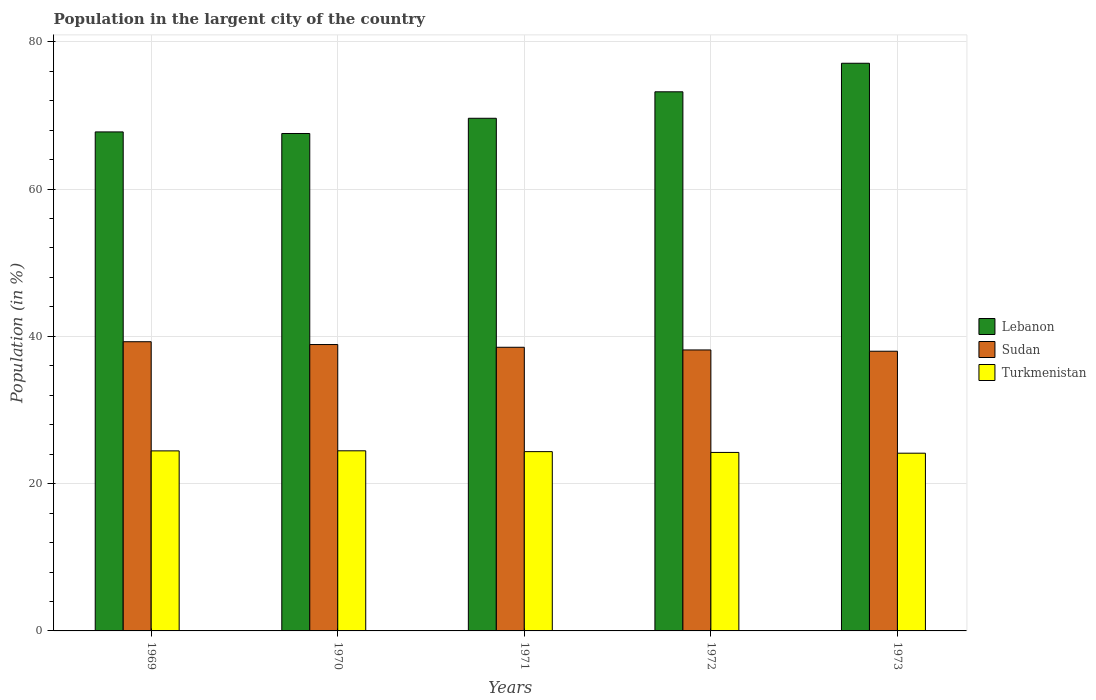How many bars are there on the 3rd tick from the left?
Your response must be concise. 3. In how many cases, is the number of bars for a given year not equal to the number of legend labels?
Offer a terse response. 0. What is the percentage of population in the largent city in Turkmenistan in 1973?
Provide a succinct answer. 24.13. Across all years, what is the maximum percentage of population in the largent city in Sudan?
Keep it short and to the point. 39.27. Across all years, what is the minimum percentage of population in the largent city in Lebanon?
Give a very brief answer. 67.54. What is the total percentage of population in the largent city in Sudan in the graph?
Keep it short and to the point. 192.79. What is the difference between the percentage of population in the largent city in Turkmenistan in 1969 and that in 1972?
Give a very brief answer. 0.21. What is the difference between the percentage of population in the largent city in Sudan in 1972 and the percentage of population in the largent city in Lebanon in 1971?
Ensure brevity in your answer.  -31.45. What is the average percentage of population in the largent city in Turkmenistan per year?
Keep it short and to the point. 24.32. In the year 1973, what is the difference between the percentage of population in the largent city in Sudan and percentage of population in the largent city in Lebanon?
Ensure brevity in your answer.  -39.1. What is the ratio of the percentage of population in the largent city in Turkmenistan in 1970 to that in 1972?
Provide a succinct answer. 1.01. Is the percentage of population in the largent city in Turkmenistan in 1970 less than that in 1971?
Keep it short and to the point. No. Is the difference between the percentage of population in the largent city in Sudan in 1970 and 1973 greater than the difference between the percentage of population in the largent city in Lebanon in 1970 and 1973?
Your answer should be compact. Yes. What is the difference between the highest and the second highest percentage of population in the largent city in Turkmenistan?
Your response must be concise. 0.01. What is the difference between the highest and the lowest percentage of population in the largent city in Sudan?
Your answer should be compact. 1.29. In how many years, is the percentage of population in the largent city in Sudan greater than the average percentage of population in the largent city in Sudan taken over all years?
Provide a succinct answer. 2. What does the 1st bar from the left in 1971 represents?
Provide a succinct answer. Lebanon. What does the 3rd bar from the right in 1969 represents?
Your answer should be compact. Lebanon. Is it the case that in every year, the sum of the percentage of population in the largent city in Turkmenistan and percentage of population in the largent city in Sudan is greater than the percentage of population in the largent city in Lebanon?
Your answer should be compact. No. How many bars are there?
Offer a terse response. 15. Are all the bars in the graph horizontal?
Make the answer very short. No. Are the values on the major ticks of Y-axis written in scientific E-notation?
Offer a terse response. No. Does the graph contain any zero values?
Offer a terse response. No. Does the graph contain grids?
Offer a terse response. Yes. Where does the legend appear in the graph?
Provide a succinct answer. Center right. How are the legend labels stacked?
Make the answer very short. Vertical. What is the title of the graph?
Your answer should be very brief. Population in the largent city of the country. Does "Cuba" appear as one of the legend labels in the graph?
Your response must be concise. No. What is the label or title of the X-axis?
Your response must be concise. Years. What is the Population (in %) of Lebanon in 1969?
Your answer should be very brief. 67.75. What is the Population (in %) of Sudan in 1969?
Your answer should be compact. 39.27. What is the Population (in %) in Turkmenistan in 1969?
Offer a very short reply. 24.44. What is the Population (in %) in Lebanon in 1970?
Offer a very short reply. 67.54. What is the Population (in %) of Sudan in 1970?
Ensure brevity in your answer.  38.88. What is the Population (in %) in Turkmenistan in 1970?
Provide a succinct answer. 24.45. What is the Population (in %) of Lebanon in 1971?
Your answer should be compact. 69.6. What is the Population (in %) in Sudan in 1971?
Offer a very short reply. 38.51. What is the Population (in %) in Turkmenistan in 1971?
Ensure brevity in your answer.  24.34. What is the Population (in %) in Lebanon in 1972?
Your answer should be compact. 73.2. What is the Population (in %) in Sudan in 1972?
Provide a succinct answer. 38.15. What is the Population (in %) of Turkmenistan in 1972?
Offer a very short reply. 24.23. What is the Population (in %) of Lebanon in 1973?
Your answer should be compact. 77.07. What is the Population (in %) in Sudan in 1973?
Provide a short and direct response. 37.98. What is the Population (in %) in Turkmenistan in 1973?
Ensure brevity in your answer.  24.13. Across all years, what is the maximum Population (in %) of Lebanon?
Your answer should be compact. 77.07. Across all years, what is the maximum Population (in %) in Sudan?
Your response must be concise. 39.27. Across all years, what is the maximum Population (in %) in Turkmenistan?
Your answer should be very brief. 24.45. Across all years, what is the minimum Population (in %) in Lebanon?
Your answer should be very brief. 67.54. Across all years, what is the minimum Population (in %) in Sudan?
Offer a terse response. 37.98. Across all years, what is the minimum Population (in %) of Turkmenistan?
Make the answer very short. 24.13. What is the total Population (in %) in Lebanon in the graph?
Your response must be concise. 355.17. What is the total Population (in %) in Sudan in the graph?
Provide a succinct answer. 192.79. What is the total Population (in %) of Turkmenistan in the graph?
Your answer should be very brief. 121.61. What is the difference between the Population (in %) of Lebanon in 1969 and that in 1970?
Offer a terse response. 0.21. What is the difference between the Population (in %) in Sudan in 1969 and that in 1970?
Your answer should be compact. 0.38. What is the difference between the Population (in %) of Turkmenistan in 1969 and that in 1970?
Make the answer very short. -0.01. What is the difference between the Population (in %) of Lebanon in 1969 and that in 1971?
Ensure brevity in your answer.  -1.85. What is the difference between the Population (in %) in Sudan in 1969 and that in 1971?
Keep it short and to the point. 0.76. What is the difference between the Population (in %) in Turkmenistan in 1969 and that in 1971?
Offer a very short reply. 0.1. What is the difference between the Population (in %) in Lebanon in 1969 and that in 1972?
Provide a short and direct response. -5.45. What is the difference between the Population (in %) of Sudan in 1969 and that in 1972?
Ensure brevity in your answer.  1.12. What is the difference between the Population (in %) in Turkmenistan in 1969 and that in 1972?
Provide a short and direct response. 0.21. What is the difference between the Population (in %) of Lebanon in 1969 and that in 1973?
Your response must be concise. -9.32. What is the difference between the Population (in %) in Sudan in 1969 and that in 1973?
Make the answer very short. 1.29. What is the difference between the Population (in %) of Turkmenistan in 1969 and that in 1973?
Give a very brief answer. 0.31. What is the difference between the Population (in %) in Lebanon in 1970 and that in 1971?
Give a very brief answer. -2.06. What is the difference between the Population (in %) of Sudan in 1970 and that in 1971?
Keep it short and to the point. 0.37. What is the difference between the Population (in %) in Turkmenistan in 1970 and that in 1971?
Offer a very short reply. 0.11. What is the difference between the Population (in %) of Lebanon in 1970 and that in 1972?
Your response must be concise. -5.66. What is the difference between the Population (in %) in Sudan in 1970 and that in 1972?
Provide a succinct answer. 0.73. What is the difference between the Population (in %) of Turkmenistan in 1970 and that in 1972?
Offer a very short reply. 0.22. What is the difference between the Population (in %) in Lebanon in 1970 and that in 1973?
Keep it short and to the point. -9.54. What is the difference between the Population (in %) of Sudan in 1970 and that in 1973?
Provide a succinct answer. 0.91. What is the difference between the Population (in %) of Turkmenistan in 1970 and that in 1973?
Your response must be concise. 0.32. What is the difference between the Population (in %) in Lebanon in 1971 and that in 1972?
Provide a succinct answer. -3.6. What is the difference between the Population (in %) in Sudan in 1971 and that in 1972?
Make the answer very short. 0.36. What is the difference between the Population (in %) of Turkmenistan in 1971 and that in 1972?
Your answer should be very brief. 0.11. What is the difference between the Population (in %) in Lebanon in 1971 and that in 1973?
Ensure brevity in your answer.  -7.47. What is the difference between the Population (in %) of Sudan in 1971 and that in 1973?
Make the answer very short. 0.54. What is the difference between the Population (in %) of Turkmenistan in 1971 and that in 1973?
Provide a short and direct response. 0.21. What is the difference between the Population (in %) of Lebanon in 1972 and that in 1973?
Keep it short and to the point. -3.88. What is the difference between the Population (in %) in Sudan in 1972 and that in 1973?
Keep it short and to the point. 0.17. What is the difference between the Population (in %) in Turkmenistan in 1972 and that in 1973?
Offer a very short reply. 0.1. What is the difference between the Population (in %) of Lebanon in 1969 and the Population (in %) of Sudan in 1970?
Keep it short and to the point. 28.87. What is the difference between the Population (in %) of Lebanon in 1969 and the Population (in %) of Turkmenistan in 1970?
Offer a very short reply. 43.3. What is the difference between the Population (in %) in Sudan in 1969 and the Population (in %) in Turkmenistan in 1970?
Your answer should be compact. 14.81. What is the difference between the Population (in %) in Lebanon in 1969 and the Population (in %) in Sudan in 1971?
Make the answer very short. 29.24. What is the difference between the Population (in %) of Lebanon in 1969 and the Population (in %) of Turkmenistan in 1971?
Ensure brevity in your answer.  43.41. What is the difference between the Population (in %) in Sudan in 1969 and the Population (in %) in Turkmenistan in 1971?
Keep it short and to the point. 14.92. What is the difference between the Population (in %) in Lebanon in 1969 and the Population (in %) in Sudan in 1972?
Provide a succinct answer. 29.6. What is the difference between the Population (in %) in Lebanon in 1969 and the Population (in %) in Turkmenistan in 1972?
Your answer should be very brief. 43.52. What is the difference between the Population (in %) in Sudan in 1969 and the Population (in %) in Turkmenistan in 1972?
Your response must be concise. 15.03. What is the difference between the Population (in %) in Lebanon in 1969 and the Population (in %) in Sudan in 1973?
Your answer should be compact. 29.78. What is the difference between the Population (in %) of Lebanon in 1969 and the Population (in %) of Turkmenistan in 1973?
Offer a very short reply. 43.62. What is the difference between the Population (in %) of Sudan in 1969 and the Population (in %) of Turkmenistan in 1973?
Offer a terse response. 15.14. What is the difference between the Population (in %) of Lebanon in 1970 and the Population (in %) of Sudan in 1971?
Provide a short and direct response. 29.03. What is the difference between the Population (in %) in Lebanon in 1970 and the Population (in %) in Turkmenistan in 1971?
Give a very brief answer. 43.2. What is the difference between the Population (in %) in Sudan in 1970 and the Population (in %) in Turkmenistan in 1971?
Keep it short and to the point. 14.54. What is the difference between the Population (in %) in Lebanon in 1970 and the Population (in %) in Sudan in 1972?
Make the answer very short. 29.39. What is the difference between the Population (in %) in Lebanon in 1970 and the Population (in %) in Turkmenistan in 1972?
Give a very brief answer. 43.3. What is the difference between the Population (in %) in Sudan in 1970 and the Population (in %) in Turkmenistan in 1972?
Provide a short and direct response. 14.65. What is the difference between the Population (in %) in Lebanon in 1970 and the Population (in %) in Sudan in 1973?
Give a very brief answer. 29.56. What is the difference between the Population (in %) of Lebanon in 1970 and the Population (in %) of Turkmenistan in 1973?
Ensure brevity in your answer.  43.41. What is the difference between the Population (in %) in Sudan in 1970 and the Population (in %) in Turkmenistan in 1973?
Give a very brief answer. 14.75. What is the difference between the Population (in %) in Lebanon in 1971 and the Population (in %) in Sudan in 1972?
Offer a very short reply. 31.45. What is the difference between the Population (in %) in Lebanon in 1971 and the Population (in %) in Turkmenistan in 1972?
Provide a short and direct response. 45.37. What is the difference between the Population (in %) of Sudan in 1971 and the Population (in %) of Turkmenistan in 1972?
Keep it short and to the point. 14.28. What is the difference between the Population (in %) of Lebanon in 1971 and the Population (in %) of Sudan in 1973?
Give a very brief answer. 31.63. What is the difference between the Population (in %) in Lebanon in 1971 and the Population (in %) in Turkmenistan in 1973?
Offer a very short reply. 45.47. What is the difference between the Population (in %) in Sudan in 1971 and the Population (in %) in Turkmenistan in 1973?
Your answer should be compact. 14.38. What is the difference between the Population (in %) in Lebanon in 1972 and the Population (in %) in Sudan in 1973?
Ensure brevity in your answer.  35.22. What is the difference between the Population (in %) of Lebanon in 1972 and the Population (in %) of Turkmenistan in 1973?
Give a very brief answer. 49.07. What is the difference between the Population (in %) in Sudan in 1972 and the Population (in %) in Turkmenistan in 1973?
Your answer should be compact. 14.02. What is the average Population (in %) in Lebanon per year?
Give a very brief answer. 71.03. What is the average Population (in %) of Sudan per year?
Keep it short and to the point. 38.56. What is the average Population (in %) of Turkmenistan per year?
Make the answer very short. 24.32. In the year 1969, what is the difference between the Population (in %) of Lebanon and Population (in %) of Sudan?
Offer a very short reply. 28.49. In the year 1969, what is the difference between the Population (in %) of Lebanon and Population (in %) of Turkmenistan?
Your answer should be compact. 43.31. In the year 1969, what is the difference between the Population (in %) in Sudan and Population (in %) in Turkmenistan?
Make the answer very short. 14.82. In the year 1970, what is the difference between the Population (in %) in Lebanon and Population (in %) in Sudan?
Offer a terse response. 28.66. In the year 1970, what is the difference between the Population (in %) in Lebanon and Population (in %) in Turkmenistan?
Provide a short and direct response. 43.08. In the year 1970, what is the difference between the Population (in %) of Sudan and Population (in %) of Turkmenistan?
Offer a very short reply. 14.43. In the year 1971, what is the difference between the Population (in %) of Lebanon and Population (in %) of Sudan?
Keep it short and to the point. 31.09. In the year 1971, what is the difference between the Population (in %) in Lebanon and Population (in %) in Turkmenistan?
Offer a terse response. 45.26. In the year 1971, what is the difference between the Population (in %) in Sudan and Population (in %) in Turkmenistan?
Make the answer very short. 14.17. In the year 1972, what is the difference between the Population (in %) in Lebanon and Population (in %) in Sudan?
Your answer should be very brief. 35.05. In the year 1972, what is the difference between the Population (in %) of Lebanon and Population (in %) of Turkmenistan?
Ensure brevity in your answer.  48.97. In the year 1972, what is the difference between the Population (in %) in Sudan and Population (in %) in Turkmenistan?
Your answer should be compact. 13.92. In the year 1973, what is the difference between the Population (in %) in Lebanon and Population (in %) in Sudan?
Your response must be concise. 39.1. In the year 1973, what is the difference between the Population (in %) in Lebanon and Population (in %) in Turkmenistan?
Offer a very short reply. 52.94. In the year 1973, what is the difference between the Population (in %) in Sudan and Population (in %) in Turkmenistan?
Your answer should be very brief. 13.85. What is the ratio of the Population (in %) in Lebanon in 1969 to that in 1970?
Ensure brevity in your answer.  1. What is the ratio of the Population (in %) in Sudan in 1969 to that in 1970?
Offer a terse response. 1.01. What is the ratio of the Population (in %) in Turkmenistan in 1969 to that in 1970?
Give a very brief answer. 1. What is the ratio of the Population (in %) in Lebanon in 1969 to that in 1971?
Keep it short and to the point. 0.97. What is the ratio of the Population (in %) in Sudan in 1969 to that in 1971?
Make the answer very short. 1.02. What is the ratio of the Population (in %) in Lebanon in 1969 to that in 1972?
Your answer should be compact. 0.93. What is the ratio of the Population (in %) of Sudan in 1969 to that in 1972?
Make the answer very short. 1.03. What is the ratio of the Population (in %) of Turkmenistan in 1969 to that in 1972?
Your answer should be very brief. 1.01. What is the ratio of the Population (in %) of Lebanon in 1969 to that in 1973?
Provide a succinct answer. 0.88. What is the ratio of the Population (in %) in Sudan in 1969 to that in 1973?
Keep it short and to the point. 1.03. What is the ratio of the Population (in %) of Turkmenistan in 1969 to that in 1973?
Make the answer very short. 1.01. What is the ratio of the Population (in %) of Lebanon in 1970 to that in 1971?
Your response must be concise. 0.97. What is the ratio of the Population (in %) of Sudan in 1970 to that in 1971?
Offer a terse response. 1.01. What is the ratio of the Population (in %) of Lebanon in 1970 to that in 1972?
Provide a short and direct response. 0.92. What is the ratio of the Population (in %) of Sudan in 1970 to that in 1972?
Offer a very short reply. 1.02. What is the ratio of the Population (in %) of Turkmenistan in 1970 to that in 1972?
Your answer should be compact. 1.01. What is the ratio of the Population (in %) of Lebanon in 1970 to that in 1973?
Provide a short and direct response. 0.88. What is the ratio of the Population (in %) of Sudan in 1970 to that in 1973?
Provide a succinct answer. 1.02. What is the ratio of the Population (in %) in Turkmenistan in 1970 to that in 1973?
Offer a terse response. 1.01. What is the ratio of the Population (in %) in Lebanon in 1971 to that in 1972?
Offer a very short reply. 0.95. What is the ratio of the Population (in %) in Sudan in 1971 to that in 1972?
Offer a very short reply. 1.01. What is the ratio of the Population (in %) of Lebanon in 1971 to that in 1973?
Provide a short and direct response. 0.9. What is the ratio of the Population (in %) in Sudan in 1971 to that in 1973?
Your response must be concise. 1.01. What is the ratio of the Population (in %) of Turkmenistan in 1971 to that in 1973?
Offer a very short reply. 1.01. What is the ratio of the Population (in %) of Lebanon in 1972 to that in 1973?
Make the answer very short. 0.95. What is the ratio of the Population (in %) of Turkmenistan in 1972 to that in 1973?
Make the answer very short. 1. What is the difference between the highest and the second highest Population (in %) in Lebanon?
Make the answer very short. 3.88. What is the difference between the highest and the second highest Population (in %) in Sudan?
Your answer should be compact. 0.38. What is the difference between the highest and the second highest Population (in %) of Turkmenistan?
Ensure brevity in your answer.  0.01. What is the difference between the highest and the lowest Population (in %) of Lebanon?
Offer a very short reply. 9.54. What is the difference between the highest and the lowest Population (in %) in Sudan?
Make the answer very short. 1.29. What is the difference between the highest and the lowest Population (in %) in Turkmenistan?
Offer a very short reply. 0.32. 